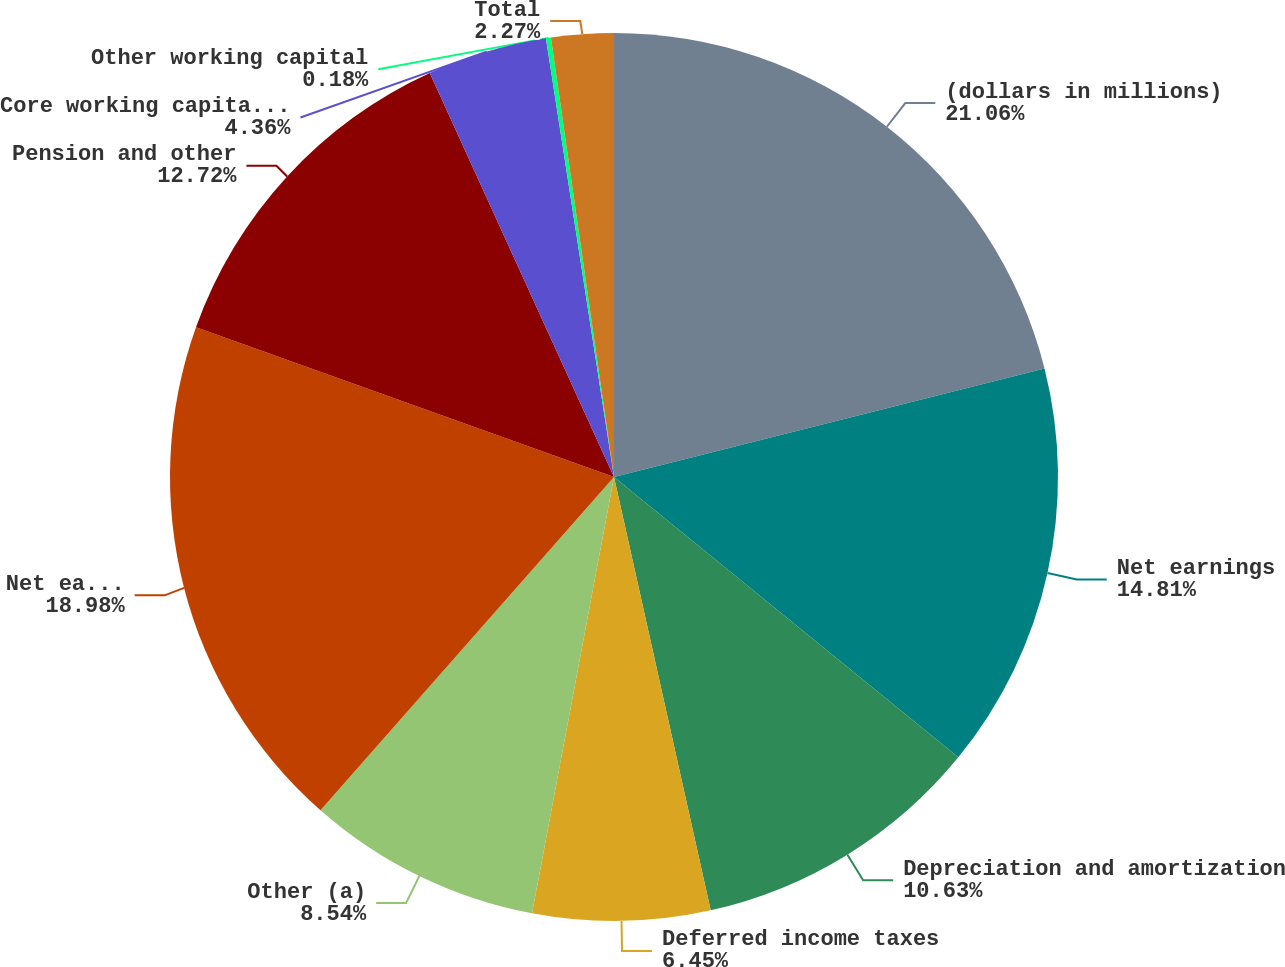Convert chart to OTSL. <chart><loc_0><loc_0><loc_500><loc_500><pie_chart><fcel>(dollars in millions)<fcel>Net earnings<fcel>Depreciation and amortization<fcel>Deferred income taxes<fcel>Other (a)<fcel>Net earnings after non-cash<fcel>Pension and other<fcel>Core working capital (b)<fcel>Other working capital<fcel>Total<nl><fcel>21.07%<fcel>14.81%<fcel>10.63%<fcel>6.45%<fcel>8.54%<fcel>18.98%<fcel>12.72%<fcel>4.36%<fcel>0.18%<fcel>2.27%<nl></chart> 